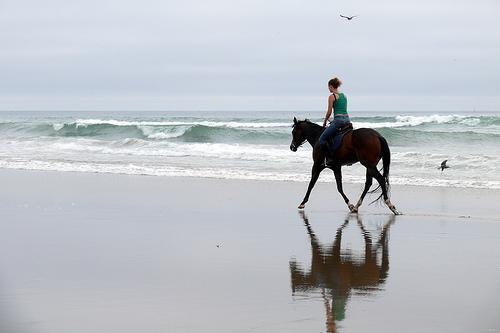How many people are in the scene?
Give a very brief answer. 1. 